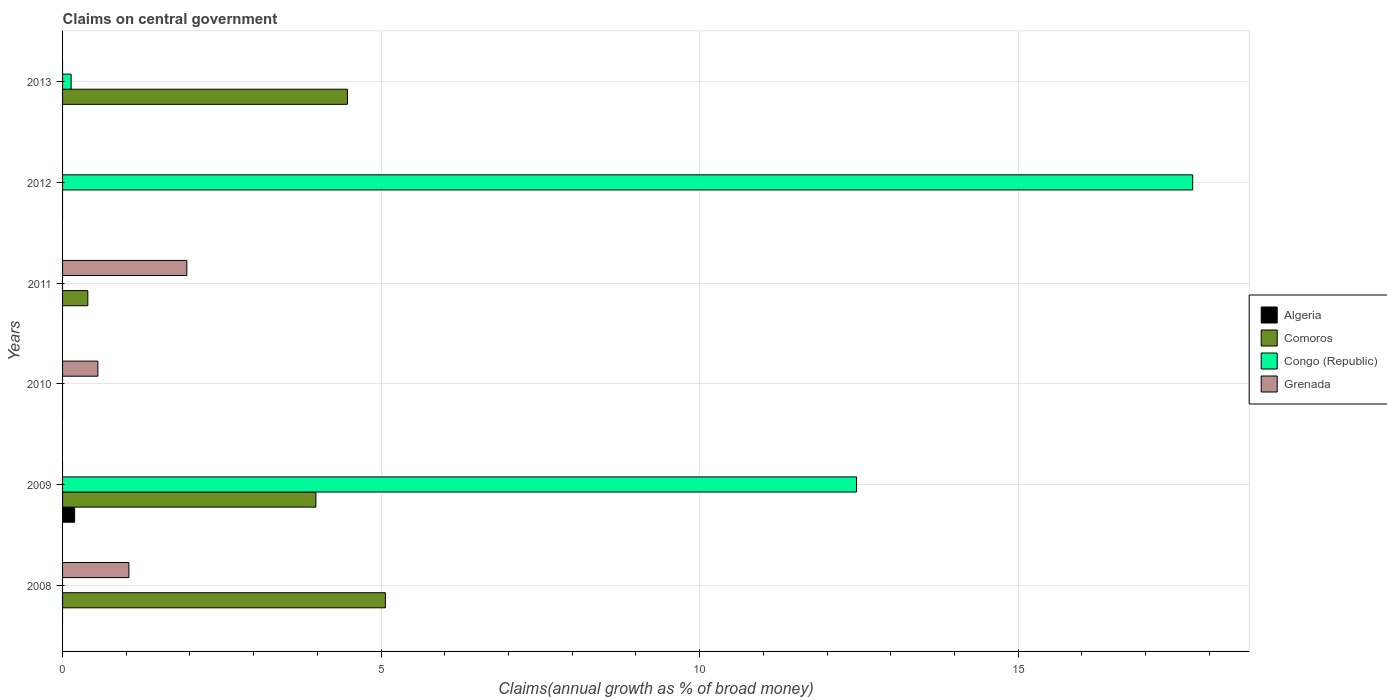Are the number of bars on each tick of the Y-axis equal?
Make the answer very short. No. How many bars are there on the 3rd tick from the bottom?
Your answer should be compact. 1. What is the label of the 5th group of bars from the top?
Offer a very short reply. 2009. In how many cases, is the number of bars for a given year not equal to the number of legend labels?
Provide a succinct answer. 6. What is the percentage of broad money claimed on centeral government in Algeria in 2009?
Provide a short and direct response. 0.19. Across all years, what is the maximum percentage of broad money claimed on centeral government in Congo (Republic)?
Offer a very short reply. 17.74. Across all years, what is the minimum percentage of broad money claimed on centeral government in Grenada?
Offer a terse response. 0. What is the total percentage of broad money claimed on centeral government in Grenada in the graph?
Your response must be concise. 3.55. What is the difference between the percentage of broad money claimed on centeral government in Grenada in 2008 and that in 2011?
Provide a short and direct response. -0.91. What is the difference between the percentage of broad money claimed on centeral government in Algeria in 2008 and the percentage of broad money claimed on centeral government in Grenada in 2012?
Keep it short and to the point. 0. What is the average percentage of broad money claimed on centeral government in Comoros per year?
Provide a short and direct response. 2.32. In the year 2009, what is the difference between the percentage of broad money claimed on centeral government in Comoros and percentage of broad money claimed on centeral government in Congo (Republic)?
Give a very brief answer. -8.49. What is the ratio of the percentage of broad money claimed on centeral government in Comoros in 2011 to that in 2013?
Give a very brief answer. 0.09. What is the difference between the highest and the second highest percentage of broad money claimed on centeral government in Grenada?
Offer a terse response. 0.91. What is the difference between the highest and the lowest percentage of broad money claimed on centeral government in Congo (Republic)?
Your answer should be very brief. 17.74. In how many years, is the percentage of broad money claimed on centeral government in Congo (Republic) greater than the average percentage of broad money claimed on centeral government in Congo (Republic) taken over all years?
Give a very brief answer. 2. Is the sum of the percentage of broad money claimed on centeral government in Congo (Republic) in 2009 and 2012 greater than the maximum percentage of broad money claimed on centeral government in Algeria across all years?
Your answer should be very brief. Yes. Is it the case that in every year, the sum of the percentage of broad money claimed on centeral government in Congo (Republic) and percentage of broad money claimed on centeral government in Algeria is greater than the sum of percentage of broad money claimed on centeral government in Grenada and percentage of broad money claimed on centeral government in Comoros?
Provide a short and direct response. No. Is it the case that in every year, the sum of the percentage of broad money claimed on centeral government in Comoros and percentage of broad money claimed on centeral government in Algeria is greater than the percentage of broad money claimed on centeral government in Grenada?
Provide a succinct answer. No. How many years are there in the graph?
Give a very brief answer. 6. Does the graph contain any zero values?
Keep it short and to the point. Yes. How are the legend labels stacked?
Keep it short and to the point. Vertical. What is the title of the graph?
Offer a terse response. Claims on central government. Does "Lebanon" appear as one of the legend labels in the graph?
Give a very brief answer. No. What is the label or title of the X-axis?
Give a very brief answer. Claims(annual growth as % of broad money). What is the label or title of the Y-axis?
Your answer should be very brief. Years. What is the Claims(annual growth as % of broad money) of Algeria in 2008?
Ensure brevity in your answer.  0. What is the Claims(annual growth as % of broad money) in Comoros in 2008?
Ensure brevity in your answer.  5.07. What is the Claims(annual growth as % of broad money) in Congo (Republic) in 2008?
Offer a very short reply. 0. What is the Claims(annual growth as % of broad money) in Grenada in 2008?
Offer a very short reply. 1.04. What is the Claims(annual growth as % of broad money) in Algeria in 2009?
Your answer should be compact. 0.19. What is the Claims(annual growth as % of broad money) of Comoros in 2009?
Your response must be concise. 3.98. What is the Claims(annual growth as % of broad money) in Congo (Republic) in 2009?
Your answer should be very brief. 12.46. What is the Claims(annual growth as % of broad money) of Grenada in 2009?
Make the answer very short. 0. What is the Claims(annual growth as % of broad money) in Algeria in 2010?
Ensure brevity in your answer.  0. What is the Claims(annual growth as % of broad money) of Comoros in 2010?
Your answer should be very brief. 0. What is the Claims(annual growth as % of broad money) of Congo (Republic) in 2010?
Give a very brief answer. 0. What is the Claims(annual growth as % of broad money) of Grenada in 2010?
Provide a succinct answer. 0.55. What is the Claims(annual growth as % of broad money) in Comoros in 2011?
Ensure brevity in your answer.  0.4. What is the Claims(annual growth as % of broad money) of Grenada in 2011?
Your response must be concise. 1.95. What is the Claims(annual growth as % of broad money) of Algeria in 2012?
Provide a short and direct response. 0. What is the Claims(annual growth as % of broad money) in Congo (Republic) in 2012?
Your response must be concise. 17.74. What is the Claims(annual growth as % of broad money) in Grenada in 2012?
Your response must be concise. 0. What is the Claims(annual growth as % of broad money) in Algeria in 2013?
Your response must be concise. 0. What is the Claims(annual growth as % of broad money) in Comoros in 2013?
Provide a short and direct response. 4.47. What is the Claims(annual growth as % of broad money) in Congo (Republic) in 2013?
Keep it short and to the point. 0.13. Across all years, what is the maximum Claims(annual growth as % of broad money) of Algeria?
Keep it short and to the point. 0.19. Across all years, what is the maximum Claims(annual growth as % of broad money) of Comoros?
Provide a short and direct response. 5.07. Across all years, what is the maximum Claims(annual growth as % of broad money) in Congo (Republic)?
Make the answer very short. 17.74. Across all years, what is the maximum Claims(annual growth as % of broad money) of Grenada?
Your response must be concise. 1.95. Across all years, what is the minimum Claims(annual growth as % of broad money) of Comoros?
Provide a succinct answer. 0. Across all years, what is the minimum Claims(annual growth as % of broad money) in Grenada?
Give a very brief answer. 0. What is the total Claims(annual growth as % of broad money) of Algeria in the graph?
Your answer should be very brief. 0.19. What is the total Claims(annual growth as % of broad money) of Comoros in the graph?
Give a very brief answer. 13.91. What is the total Claims(annual growth as % of broad money) in Congo (Republic) in the graph?
Provide a short and direct response. 30.34. What is the total Claims(annual growth as % of broad money) in Grenada in the graph?
Offer a terse response. 3.55. What is the difference between the Claims(annual growth as % of broad money) in Comoros in 2008 and that in 2009?
Make the answer very short. 1.09. What is the difference between the Claims(annual growth as % of broad money) of Grenada in 2008 and that in 2010?
Ensure brevity in your answer.  0.49. What is the difference between the Claims(annual growth as % of broad money) of Comoros in 2008 and that in 2011?
Make the answer very short. 4.67. What is the difference between the Claims(annual growth as % of broad money) of Grenada in 2008 and that in 2011?
Your answer should be very brief. -0.91. What is the difference between the Claims(annual growth as % of broad money) of Comoros in 2008 and that in 2013?
Provide a succinct answer. 0.6. What is the difference between the Claims(annual growth as % of broad money) of Comoros in 2009 and that in 2011?
Give a very brief answer. 3.58. What is the difference between the Claims(annual growth as % of broad money) in Congo (Republic) in 2009 and that in 2012?
Your response must be concise. -5.28. What is the difference between the Claims(annual growth as % of broad money) in Comoros in 2009 and that in 2013?
Provide a succinct answer. -0.49. What is the difference between the Claims(annual growth as % of broad money) of Congo (Republic) in 2009 and that in 2013?
Give a very brief answer. 12.33. What is the difference between the Claims(annual growth as % of broad money) in Grenada in 2010 and that in 2011?
Ensure brevity in your answer.  -1.4. What is the difference between the Claims(annual growth as % of broad money) of Comoros in 2011 and that in 2013?
Offer a terse response. -4.07. What is the difference between the Claims(annual growth as % of broad money) of Congo (Republic) in 2012 and that in 2013?
Provide a succinct answer. 17.6. What is the difference between the Claims(annual growth as % of broad money) in Comoros in 2008 and the Claims(annual growth as % of broad money) in Congo (Republic) in 2009?
Your response must be concise. -7.4. What is the difference between the Claims(annual growth as % of broad money) in Comoros in 2008 and the Claims(annual growth as % of broad money) in Grenada in 2010?
Make the answer very short. 4.51. What is the difference between the Claims(annual growth as % of broad money) of Comoros in 2008 and the Claims(annual growth as % of broad money) of Grenada in 2011?
Keep it short and to the point. 3.12. What is the difference between the Claims(annual growth as % of broad money) in Comoros in 2008 and the Claims(annual growth as % of broad money) in Congo (Republic) in 2012?
Your answer should be very brief. -12.67. What is the difference between the Claims(annual growth as % of broad money) of Comoros in 2008 and the Claims(annual growth as % of broad money) of Congo (Republic) in 2013?
Ensure brevity in your answer.  4.93. What is the difference between the Claims(annual growth as % of broad money) in Algeria in 2009 and the Claims(annual growth as % of broad money) in Grenada in 2010?
Ensure brevity in your answer.  -0.36. What is the difference between the Claims(annual growth as % of broad money) of Comoros in 2009 and the Claims(annual growth as % of broad money) of Grenada in 2010?
Ensure brevity in your answer.  3.42. What is the difference between the Claims(annual growth as % of broad money) of Congo (Republic) in 2009 and the Claims(annual growth as % of broad money) of Grenada in 2010?
Offer a terse response. 11.91. What is the difference between the Claims(annual growth as % of broad money) of Algeria in 2009 and the Claims(annual growth as % of broad money) of Comoros in 2011?
Offer a terse response. -0.21. What is the difference between the Claims(annual growth as % of broad money) in Algeria in 2009 and the Claims(annual growth as % of broad money) in Grenada in 2011?
Offer a terse response. -1.76. What is the difference between the Claims(annual growth as % of broad money) in Comoros in 2009 and the Claims(annual growth as % of broad money) in Grenada in 2011?
Offer a terse response. 2.03. What is the difference between the Claims(annual growth as % of broad money) of Congo (Republic) in 2009 and the Claims(annual growth as % of broad money) of Grenada in 2011?
Your answer should be compact. 10.51. What is the difference between the Claims(annual growth as % of broad money) of Algeria in 2009 and the Claims(annual growth as % of broad money) of Congo (Republic) in 2012?
Provide a short and direct response. -17.55. What is the difference between the Claims(annual growth as % of broad money) of Comoros in 2009 and the Claims(annual growth as % of broad money) of Congo (Republic) in 2012?
Your answer should be compact. -13.76. What is the difference between the Claims(annual growth as % of broad money) of Algeria in 2009 and the Claims(annual growth as % of broad money) of Comoros in 2013?
Provide a succinct answer. -4.28. What is the difference between the Claims(annual growth as % of broad money) of Algeria in 2009 and the Claims(annual growth as % of broad money) of Congo (Republic) in 2013?
Ensure brevity in your answer.  0.05. What is the difference between the Claims(annual growth as % of broad money) of Comoros in 2009 and the Claims(annual growth as % of broad money) of Congo (Republic) in 2013?
Give a very brief answer. 3.84. What is the difference between the Claims(annual growth as % of broad money) of Comoros in 2011 and the Claims(annual growth as % of broad money) of Congo (Republic) in 2012?
Your answer should be compact. -17.34. What is the difference between the Claims(annual growth as % of broad money) of Comoros in 2011 and the Claims(annual growth as % of broad money) of Congo (Republic) in 2013?
Offer a very short reply. 0.26. What is the average Claims(annual growth as % of broad money) in Algeria per year?
Your response must be concise. 0.03. What is the average Claims(annual growth as % of broad money) in Comoros per year?
Your answer should be compact. 2.32. What is the average Claims(annual growth as % of broad money) in Congo (Republic) per year?
Your answer should be compact. 5.06. What is the average Claims(annual growth as % of broad money) in Grenada per year?
Keep it short and to the point. 0.59. In the year 2008, what is the difference between the Claims(annual growth as % of broad money) in Comoros and Claims(annual growth as % of broad money) in Grenada?
Your answer should be compact. 4.03. In the year 2009, what is the difference between the Claims(annual growth as % of broad money) in Algeria and Claims(annual growth as % of broad money) in Comoros?
Your answer should be compact. -3.79. In the year 2009, what is the difference between the Claims(annual growth as % of broad money) of Algeria and Claims(annual growth as % of broad money) of Congo (Republic)?
Give a very brief answer. -12.27. In the year 2009, what is the difference between the Claims(annual growth as % of broad money) of Comoros and Claims(annual growth as % of broad money) of Congo (Republic)?
Provide a short and direct response. -8.49. In the year 2011, what is the difference between the Claims(annual growth as % of broad money) in Comoros and Claims(annual growth as % of broad money) in Grenada?
Offer a very short reply. -1.55. In the year 2013, what is the difference between the Claims(annual growth as % of broad money) in Comoros and Claims(annual growth as % of broad money) in Congo (Republic)?
Give a very brief answer. 4.34. What is the ratio of the Claims(annual growth as % of broad money) of Comoros in 2008 to that in 2009?
Offer a terse response. 1.27. What is the ratio of the Claims(annual growth as % of broad money) of Grenada in 2008 to that in 2010?
Ensure brevity in your answer.  1.88. What is the ratio of the Claims(annual growth as % of broad money) of Comoros in 2008 to that in 2011?
Give a very brief answer. 12.78. What is the ratio of the Claims(annual growth as % of broad money) of Grenada in 2008 to that in 2011?
Ensure brevity in your answer.  0.53. What is the ratio of the Claims(annual growth as % of broad money) of Comoros in 2008 to that in 2013?
Offer a terse response. 1.13. What is the ratio of the Claims(annual growth as % of broad money) of Comoros in 2009 to that in 2011?
Provide a short and direct response. 10.03. What is the ratio of the Claims(annual growth as % of broad money) of Congo (Republic) in 2009 to that in 2012?
Your response must be concise. 0.7. What is the ratio of the Claims(annual growth as % of broad money) in Comoros in 2009 to that in 2013?
Keep it short and to the point. 0.89. What is the ratio of the Claims(annual growth as % of broad money) in Congo (Republic) in 2009 to that in 2013?
Keep it short and to the point. 92.46. What is the ratio of the Claims(annual growth as % of broad money) of Grenada in 2010 to that in 2011?
Ensure brevity in your answer.  0.28. What is the ratio of the Claims(annual growth as % of broad money) of Comoros in 2011 to that in 2013?
Make the answer very short. 0.09. What is the ratio of the Claims(annual growth as % of broad money) in Congo (Republic) in 2012 to that in 2013?
Give a very brief answer. 131.59. What is the difference between the highest and the second highest Claims(annual growth as % of broad money) in Comoros?
Ensure brevity in your answer.  0.6. What is the difference between the highest and the second highest Claims(annual growth as % of broad money) in Congo (Republic)?
Your response must be concise. 5.28. What is the difference between the highest and the second highest Claims(annual growth as % of broad money) in Grenada?
Offer a very short reply. 0.91. What is the difference between the highest and the lowest Claims(annual growth as % of broad money) in Algeria?
Your answer should be compact. 0.19. What is the difference between the highest and the lowest Claims(annual growth as % of broad money) of Comoros?
Make the answer very short. 5.07. What is the difference between the highest and the lowest Claims(annual growth as % of broad money) of Congo (Republic)?
Keep it short and to the point. 17.74. What is the difference between the highest and the lowest Claims(annual growth as % of broad money) in Grenada?
Keep it short and to the point. 1.95. 